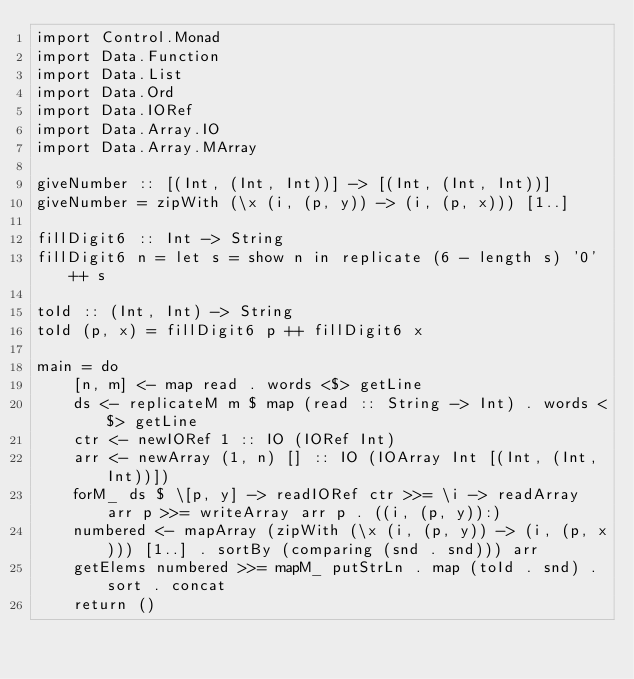Convert code to text. <code><loc_0><loc_0><loc_500><loc_500><_Haskell_>import Control.Monad
import Data.Function
import Data.List
import Data.Ord
import Data.IORef
import Data.Array.IO
import Data.Array.MArray

giveNumber :: [(Int, (Int, Int))] -> [(Int, (Int, Int))]
giveNumber = zipWith (\x (i, (p, y)) -> (i, (p, x))) [1..]

fillDigit6 :: Int -> String
fillDigit6 n = let s = show n in replicate (6 - length s) '0' ++ s

toId :: (Int, Int) -> String
toId (p, x) = fillDigit6 p ++ fillDigit6 x

main = do
    [n, m] <- map read . words <$> getLine
    ds <- replicateM m $ map (read :: String -> Int) . words <$> getLine
    ctr <- newIORef 1 :: IO (IORef Int)
    arr <- newArray (1, n) [] :: IO (IOArray Int [(Int, (Int, Int))])
    forM_ ds $ \[p, y] -> readIORef ctr >>= \i -> readArray arr p >>= writeArray arr p . ((i, (p, y)):)
    numbered <- mapArray (zipWith (\x (i, (p, y)) -> (i, (p, x))) [1..] . sortBy (comparing (snd . snd))) arr
    getElems numbered >>= mapM_ putStrLn . map (toId . snd) . sort . concat
    return ()</code> 